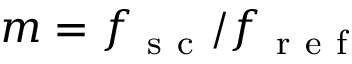<formula> <loc_0><loc_0><loc_500><loc_500>m = f _ { s c } / f _ { r e f }</formula> 